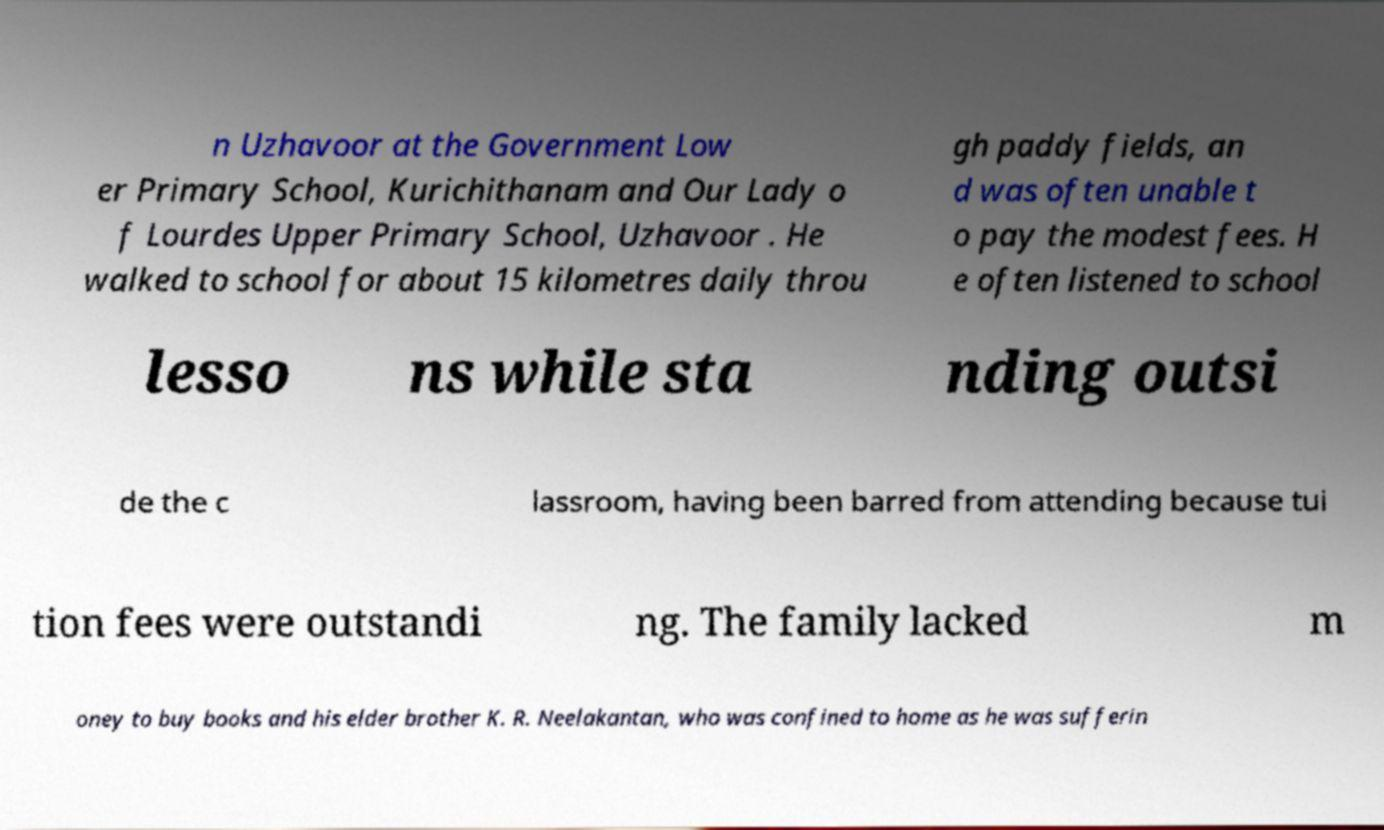Please read and relay the text visible in this image. What does it say? n Uzhavoor at the Government Low er Primary School, Kurichithanam and Our Lady o f Lourdes Upper Primary School, Uzhavoor . He walked to school for about 15 kilometres daily throu gh paddy fields, an d was often unable t o pay the modest fees. H e often listened to school lesso ns while sta nding outsi de the c lassroom, having been barred from attending because tui tion fees were outstandi ng. The family lacked m oney to buy books and his elder brother K. R. Neelakantan, who was confined to home as he was sufferin 